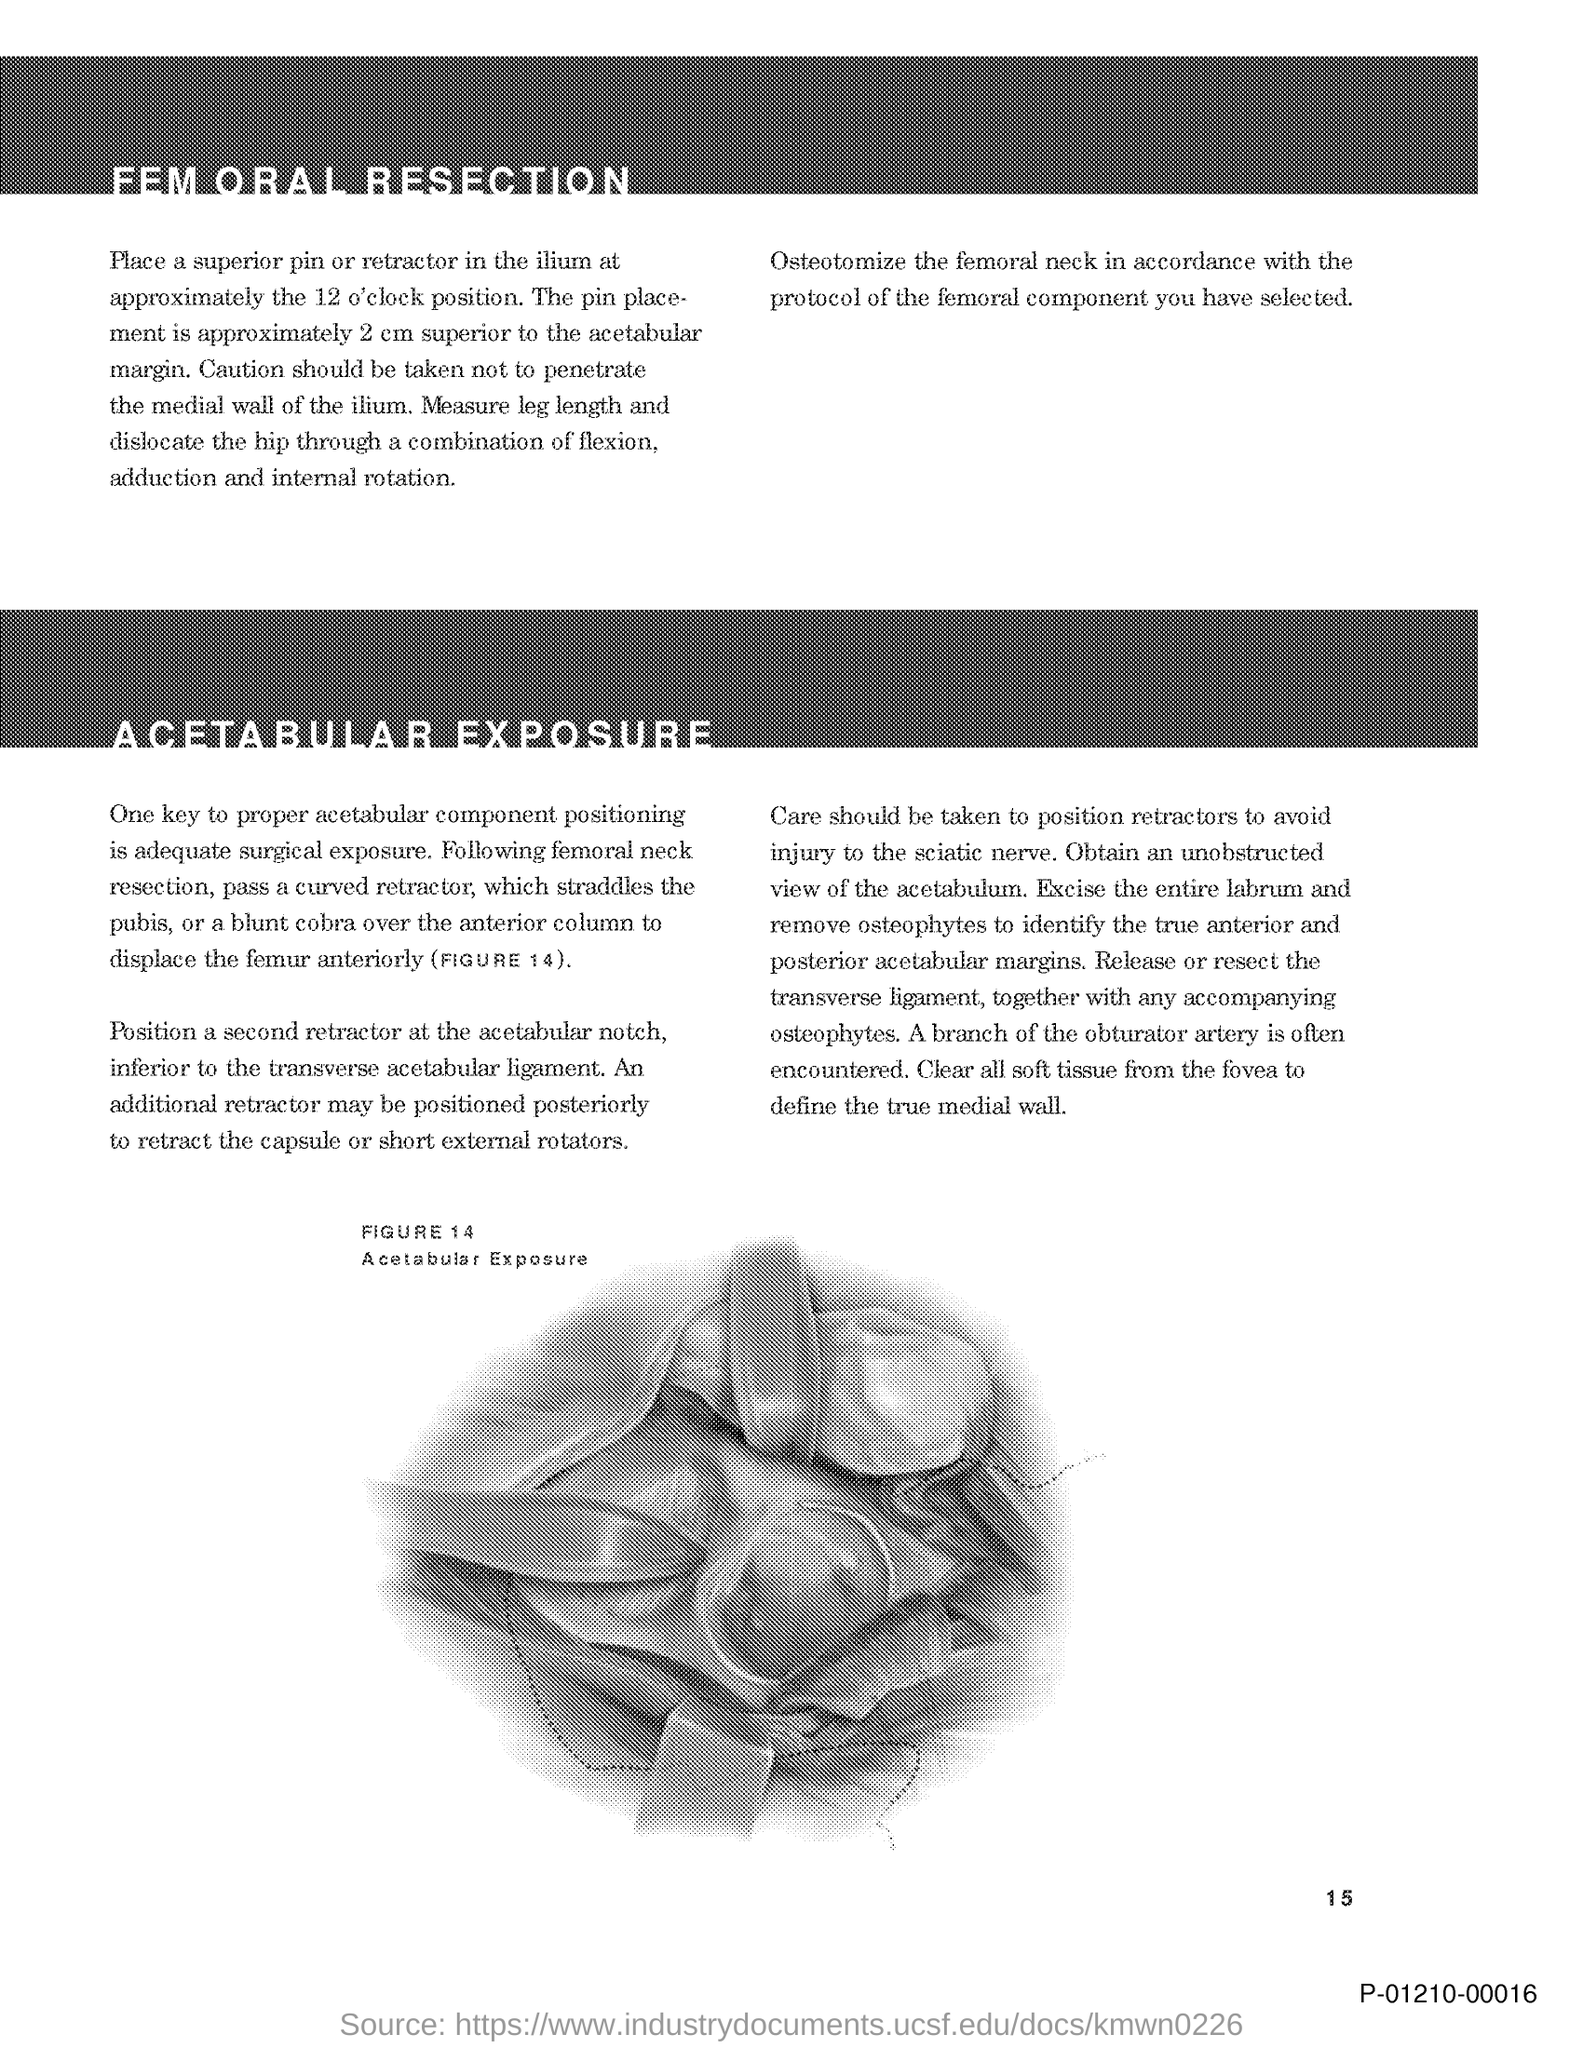What precautions are mentioned in this document for the procedure? The precautions include the placement of pins or retractors without penetrating the medial wall of the ilium, avoiding injury to the sciatic nerve, and ensuring clear visualization of surgical landmarks. And how is the femoral neck involved in this procedure? The procedure requires an osteotomy of the femoral neck, following a specific protocol. This is a critical step to prepare for the proper positioning or replacement of the femoral component in hip surgery. 